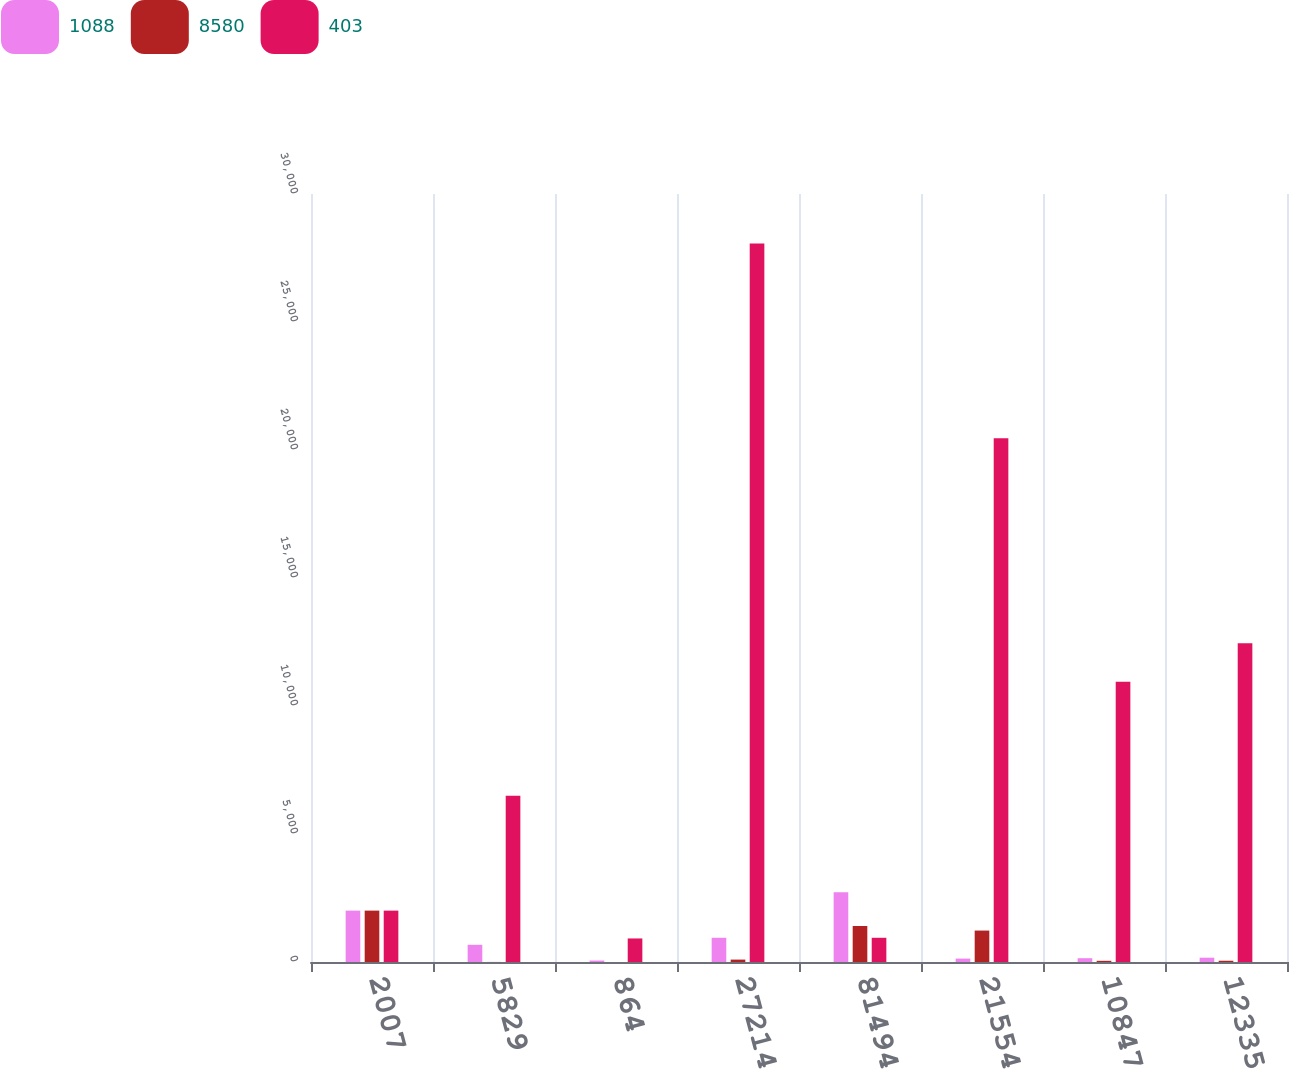Convert chart to OTSL. <chart><loc_0><loc_0><loc_500><loc_500><stacked_bar_chart><ecel><fcel>2007<fcel>5829<fcel>864<fcel>27214<fcel>81494<fcel>21554<fcel>10847<fcel>12335<nl><fcel>1088<fcel>2007<fcel>671<fcel>57<fcel>946<fcel>2728<fcel>133<fcel>148<fcel>168<nl><fcel>8580<fcel>2007<fcel>2<fcel>1<fcel>94<fcel>1406<fcel>1228<fcel>46<fcel>49<nl><fcel>403<fcel>2007<fcel>6498<fcel>920<fcel>28066<fcel>946<fcel>20459<fcel>10949<fcel>12454<nl></chart> 